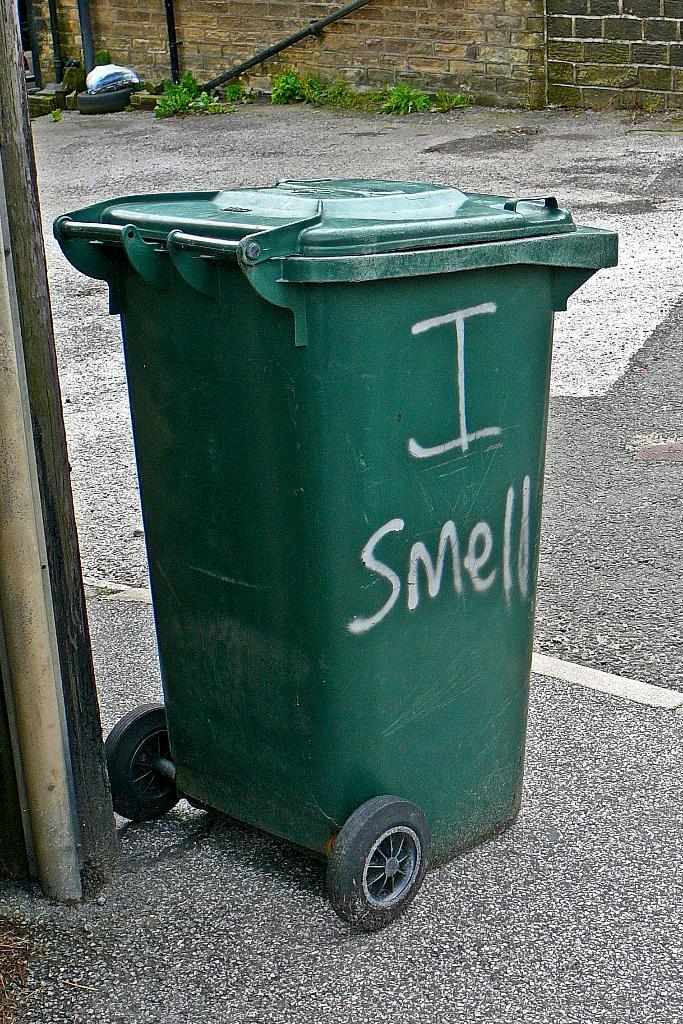What does the graffiti on the trashcan say?
Your answer should be compact. I smell. 